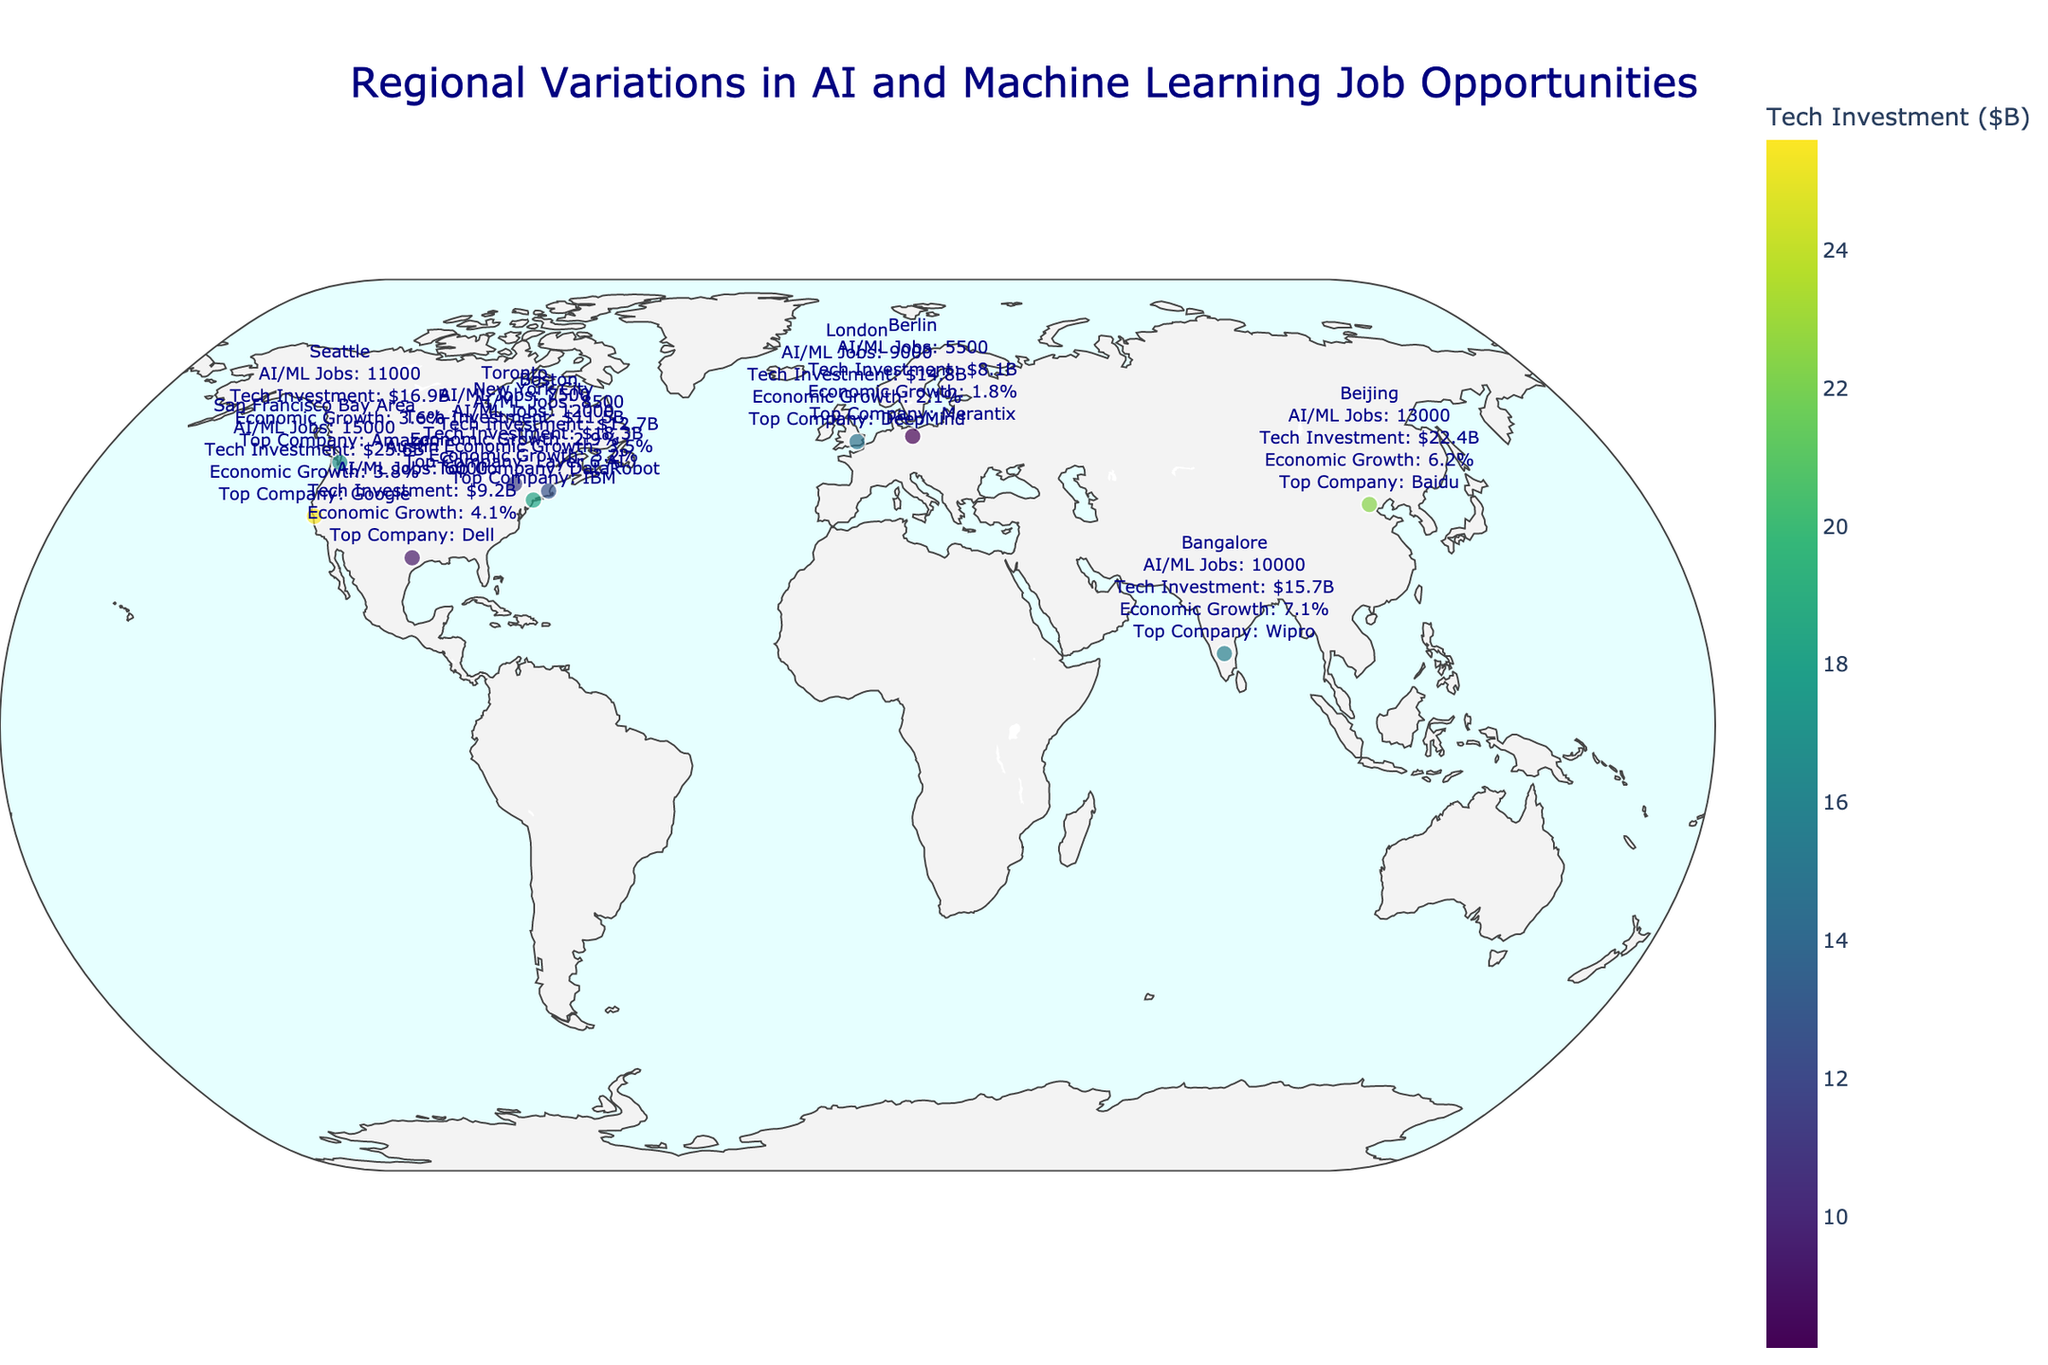What is the title of the figure? The title is usually displayed at the top of the chart and provides an overview of the content. In this case, we can see it says "Regional Variations in AI and Machine Learning Job Opportunities".
Answer: Regional Variations in AI and Machine Learning Job Opportunities Which region has the highest number of AI/ML job opportunities? The figure indicates the number of AI/ML jobs for each region with varying marker sizes on the map. The largest marker corresponds to the San Francisco Bay Area with 15,000 jobs.
Answer: San Francisco Bay Area What is the color of the marker for Berlin, and what does it represent? Marker colors represent tech investments and follow a color scale from low to high. Berlin's marker is on the lower end of the color scale, indicating its tech investment value of $8.1B.
Answer: It is a darker shade representing a tech investment of $8.1B How does the economic growth of Beijing compare to San Francisco Bay Area? By viewing the text popups, Beijing's economic growth is 6.2%, which is higher than San Francisco Bay Area's 3.8%.
Answer: Beijing has higher economic growth (6.2%) than San Francisco Bay Area (3.8%) Which region has the smallest number of AI/ML job opportunities and what company is top there? The smallest marker on the map is for Berlin with 5,500 AI/ML jobs. The top company in Berlin is Merantix.
Answer: Berlin with Merantix Calculate the average number of AI/ML job opportunities across all listed regions. To find this, sum all the job numbers and divide by the number of regions. The sum is (15000+12000+8500+11000+6000+7500+9000+5500+13000+10000) = 97500. Dividing by 10 regions gives 9750.
Answer: 9,750 Which region has the highest tech investment, and how does its economic growth compare to the region with the smallest tech investment? Referencing the color scale, San Francisco Bay Area has the highest tech investment at $25.6B and Berlin the smallest at $8.1B. San Francisco has an economic growth of 3.8%, while Berlin's is 1.8%, making San Francisco's economic growth higher.
Answer: San Francisco Bay Area has higher economic growth (3.8% vs. 1.8%) What geographical scope is used in the figure? The geographical layout encompasses the world, indicated by the plot spanning regions from North America, Europe, and Asia. The title and the regions included confirm this.
Answer: World Which region has higher AI/ML job opportunities, New York City or Bangalore, and by how much? New York City has 12,000 AI/ML jobs while Bangalore has 10,000. The difference is 12,000 - 10,000 = 2,000.
Answer: New York City by 2,000 Compare the tech investments of London and Boston and determine which one is higher and by what value. Checking the text popups, London's tech investment is $14.8B while Boston's is $12.7B. The difference is $14.8B - $12.7B = $2.1B.
Answer: London by $2.1B 